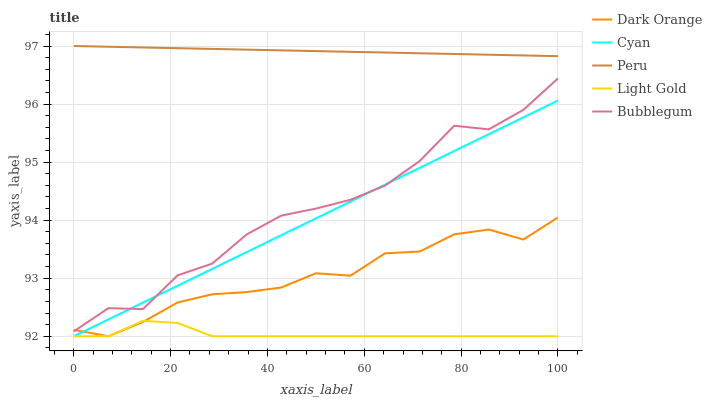Does Light Gold have the minimum area under the curve?
Answer yes or no. Yes. Does Peru have the maximum area under the curve?
Answer yes or no. Yes. Does Bubblegum have the minimum area under the curve?
Answer yes or no. No. Does Bubblegum have the maximum area under the curve?
Answer yes or no. No. Is Peru the smoothest?
Answer yes or no. Yes. Is Bubblegum the roughest?
Answer yes or no. Yes. Is Light Gold the smoothest?
Answer yes or no. No. Is Light Gold the roughest?
Answer yes or no. No. Does Bubblegum have the lowest value?
Answer yes or no. No. Does Peru have the highest value?
Answer yes or no. Yes. Does Bubblegum have the highest value?
Answer yes or no. No. Is Bubblegum less than Peru?
Answer yes or no. Yes. Is Peru greater than Cyan?
Answer yes or no. Yes. Does Bubblegum intersect Peru?
Answer yes or no. No. 